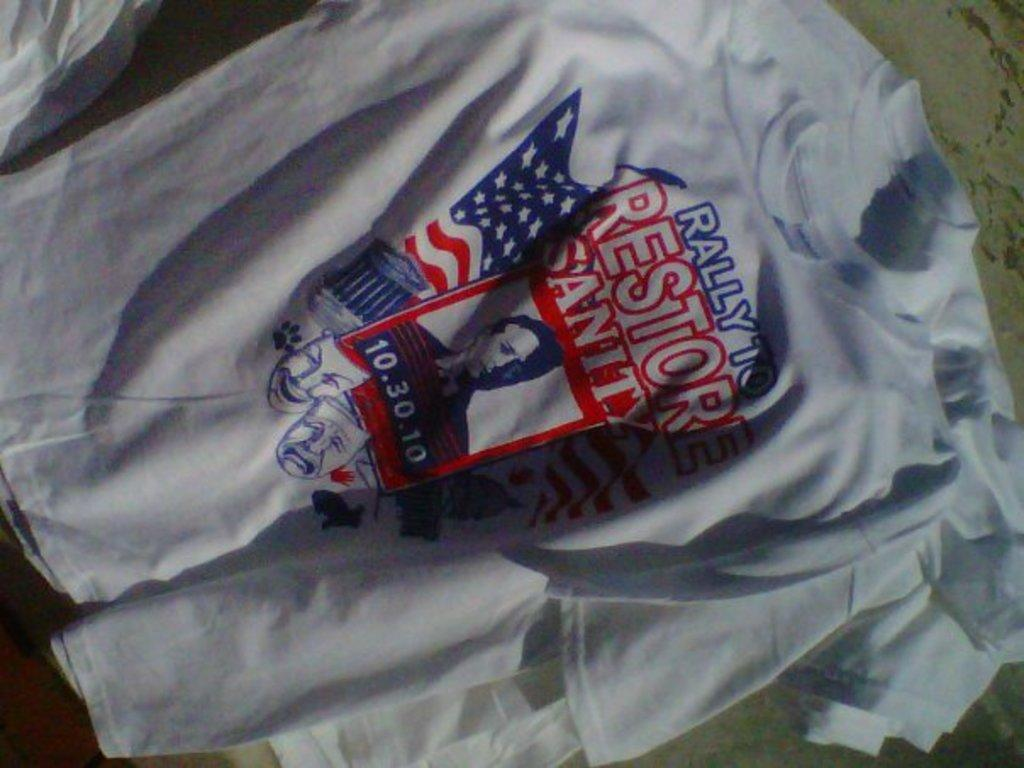<image>
Create a compact narrative representing the image presented. A red white and blue themed Rally to Restore Sanity T-shirt. 